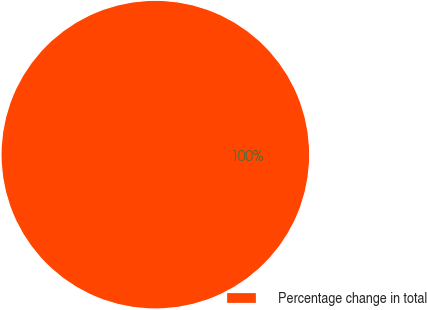Convert chart. <chart><loc_0><loc_0><loc_500><loc_500><pie_chart><fcel>Percentage change in total<nl><fcel>100.0%<nl></chart> 